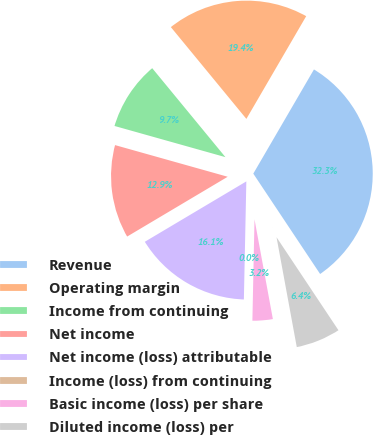Convert chart to OTSL. <chart><loc_0><loc_0><loc_500><loc_500><pie_chart><fcel>Revenue<fcel>Operating margin<fcel>Income from continuing<fcel>Net income<fcel>Net income (loss) attributable<fcel>Income (loss) from continuing<fcel>Basic income (loss) per share<fcel>Diluted income (loss) per<nl><fcel>32.26%<fcel>19.35%<fcel>9.68%<fcel>12.9%<fcel>16.13%<fcel>0.0%<fcel>3.23%<fcel>6.45%<nl></chart> 